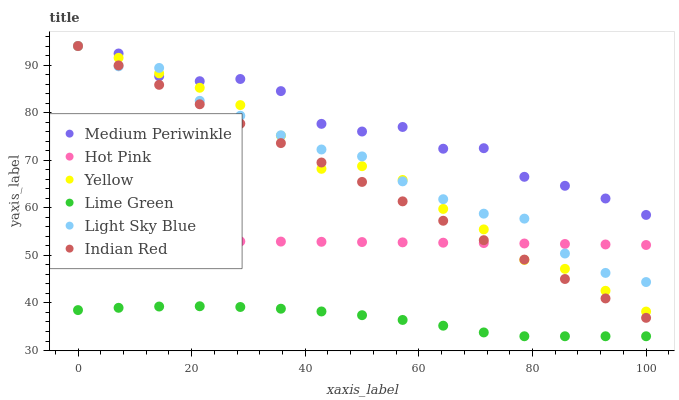Does Lime Green have the minimum area under the curve?
Answer yes or no. Yes. Does Medium Periwinkle have the maximum area under the curve?
Answer yes or no. Yes. Does Yellow have the minimum area under the curve?
Answer yes or no. No. Does Yellow have the maximum area under the curve?
Answer yes or no. No. Is Indian Red the smoothest?
Answer yes or no. Yes. Is Medium Periwinkle the roughest?
Answer yes or no. Yes. Is Yellow the smoothest?
Answer yes or no. No. Is Yellow the roughest?
Answer yes or no. No. Does Lime Green have the lowest value?
Answer yes or no. Yes. Does Yellow have the lowest value?
Answer yes or no. No. Does Indian Red have the highest value?
Answer yes or no. Yes. Does Lime Green have the highest value?
Answer yes or no. No. Is Hot Pink less than Medium Periwinkle?
Answer yes or no. Yes. Is Hot Pink greater than Lime Green?
Answer yes or no. Yes. Does Medium Periwinkle intersect Light Sky Blue?
Answer yes or no. Yes. Is Medium Periwinkle less than Light Sky Blue?
Answer yes or no. No. Is Medium Periwinkle greater than Light Sky Blue?
Answer yes or no. No. Does Hot Pink intersect Medium Periwinkle?
Answer yes or no. No. 